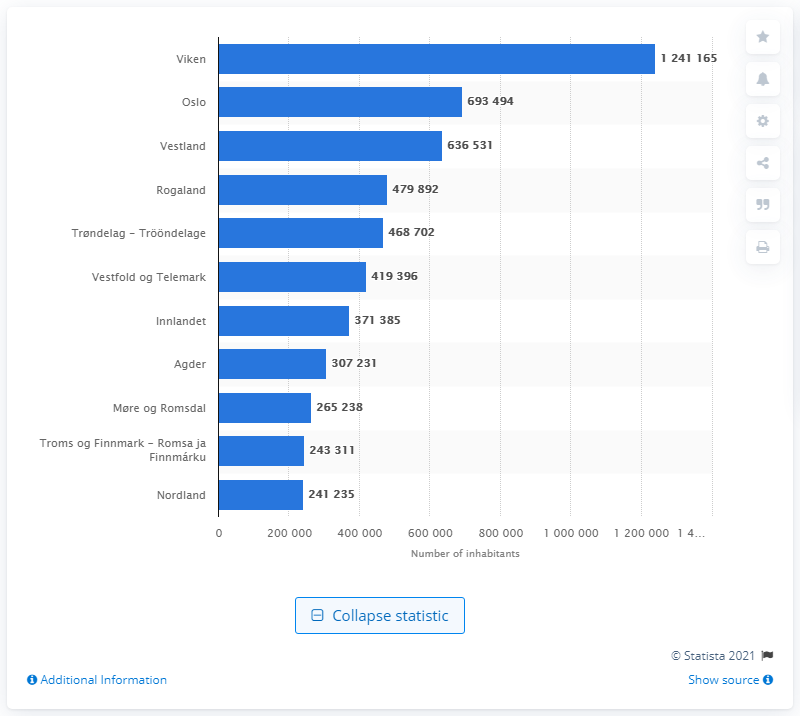Specify some key components in this picture. As of the latest available data, approximately 243,311 individuals reside in Troms og Finnmark. Viken is the most populous county in Norway. 